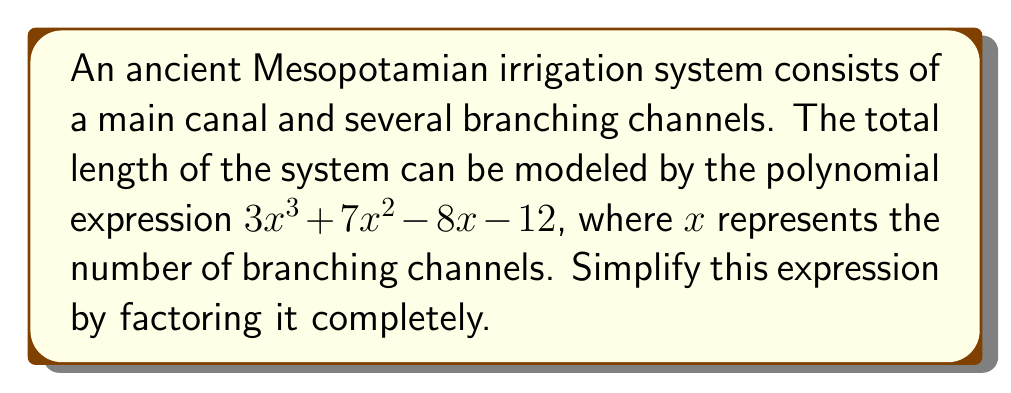Can you solve this math problem? To simplify this polynomial expression by factoring, we'll follow these steps:

1) First, let's check if there's a greatest common factor (GCF):
   $3x^3 + 7x^2 - 8x - 12$
   There is no common factor for all terms, so we proceed.

2) This is a cubic equation. Let's try to factor out a linear term if possible.
   We can use the rational root theorem to find potential roots.
   Factors of the constant term (12) are: ±1, ±2, ±3, ±4, ±6, ±12
   
3) Testing these values, we find that $x = 1$ is a root.
   
4) We can factor out $(x - 1)$:
   $3x^3 + 7x^2 - 8x - 12 = (x - 1)(3x^2 + 10x + 12)$

5) Now we need to factor the quadratic term $3x^2 + 10x + 12$
   We can use the ac-method:
   $ac = 3 * 12 = 36$
   We need to find two numbers that multiply to give 36 and add to give 10.
   These numbers are 6 and 4.

6) Rewrite the middle term:
   $3x^2 + 6x + 4x + 12$

7) Group the terms:
   $(3x^2 + 6x) + (4x + 12)$
   $3x(x + 2) + 4(x + 3)$

8) Factor out the common binomial:
   $(x + 2)(3x) + (x + 2)(4)$
   $(x + 2)(3x + 4)$

9) Combining all factors:
   $3x^3 + 7x^2 - 8x - 12 = (x - 1)(x + 2)(3x + 4)$

This is the fully factored form of the polynomial.
Answer: $(x - 1)(x + 2)(3x + 4)$ 